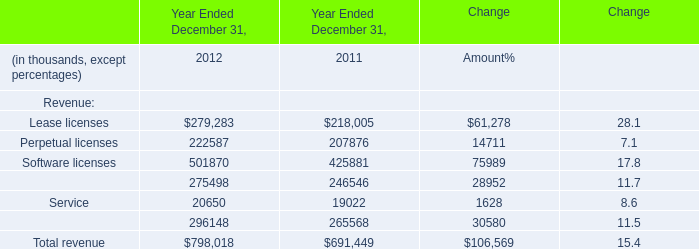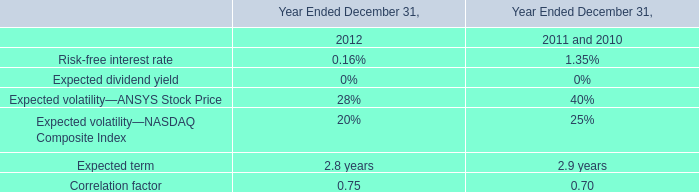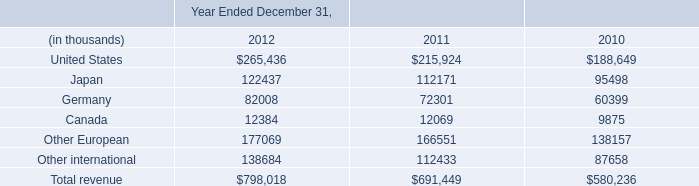In the year with the most software licenses, what is the growth rate of Service? 
Computations: ((20650 - 19022) / 19022)
Answer: 0.08559. 